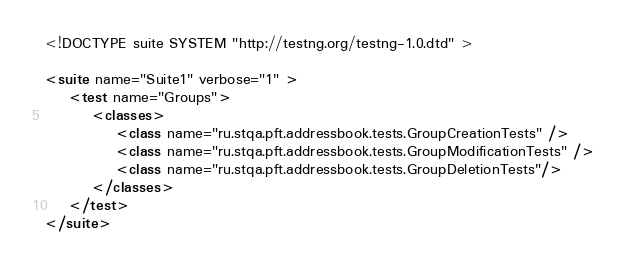Convert code to text. <code><loc_0><loc_0><loc_500><loc_500><_XML_><!DOCTYPE suite SYSTEM "http://testng.org/testng-1.0.dtd" >

<suite name="Suite1" verbose="1" >
    <test name="Groups">
        <classes>
            <class name="ru.stqa.pft.addressbook.tests.GroupCreationTests" />
            <class name="ru.stqa.pft.addressbook.tests.GroupModificationTests" />
            <class name="ru.stqa.pft.addressbook.tests.GroupDeletionTests"/>
        </classes>
    </test>
</suite>
</code> 